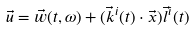Convert formula to latex. <formula><loc_0><loc_0><loc_500><loc_500>\vec { u } = \vec { w } ( t , \omega ) + ( \vec { k } ^ { i } ( t ) \cdot \vec { x } ) \vec { l } ^ { i } ( t )</formula> 